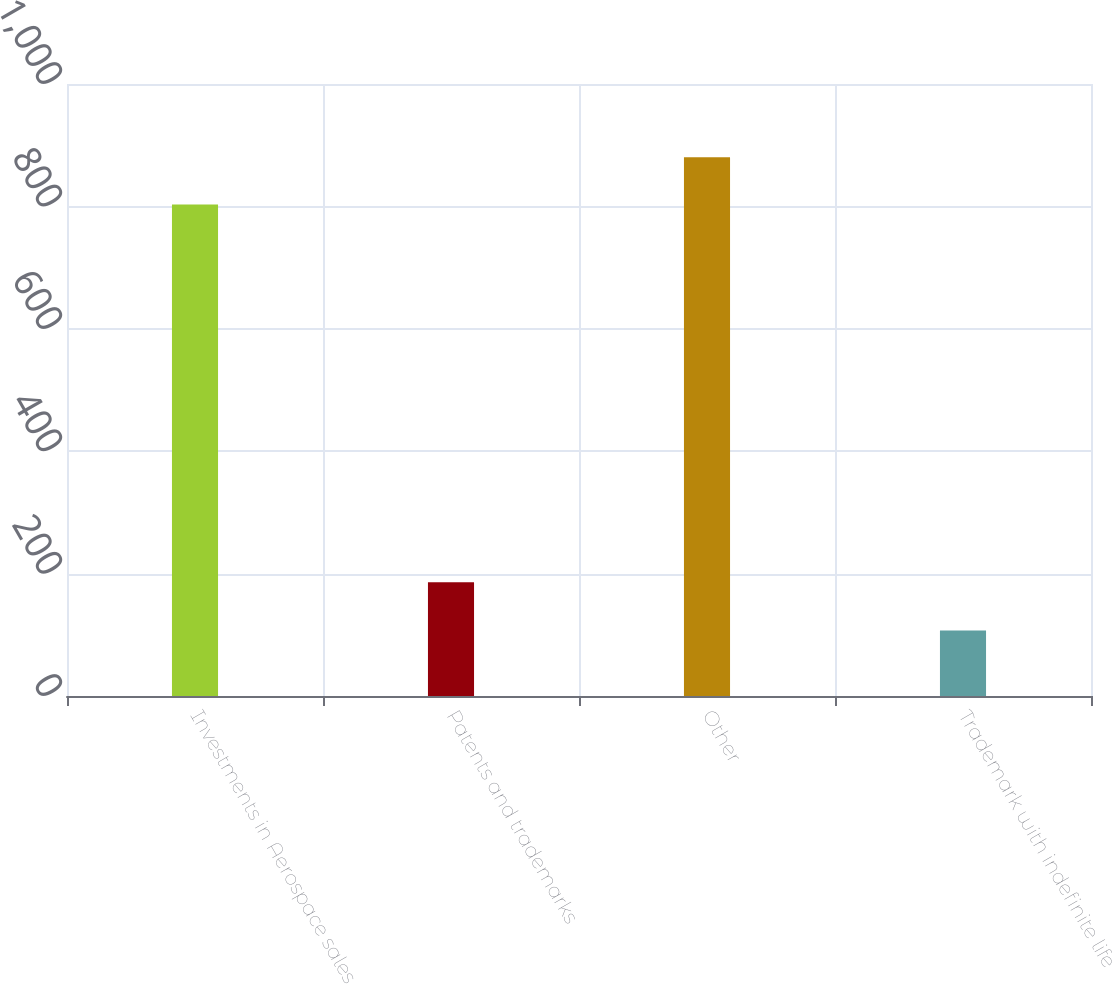Convert chart to OTSL. <chart><loc_0><loc_0><loc_500><loc_500><bar_chart><fcel>Investments in Aerospace sales<fcel>Patents and trademarks<fcel>Other<fcel>Trademark with indefinite life<nl><fcel>803<fcel>186<fcel>880.3<fcel>107<nl></chart> 